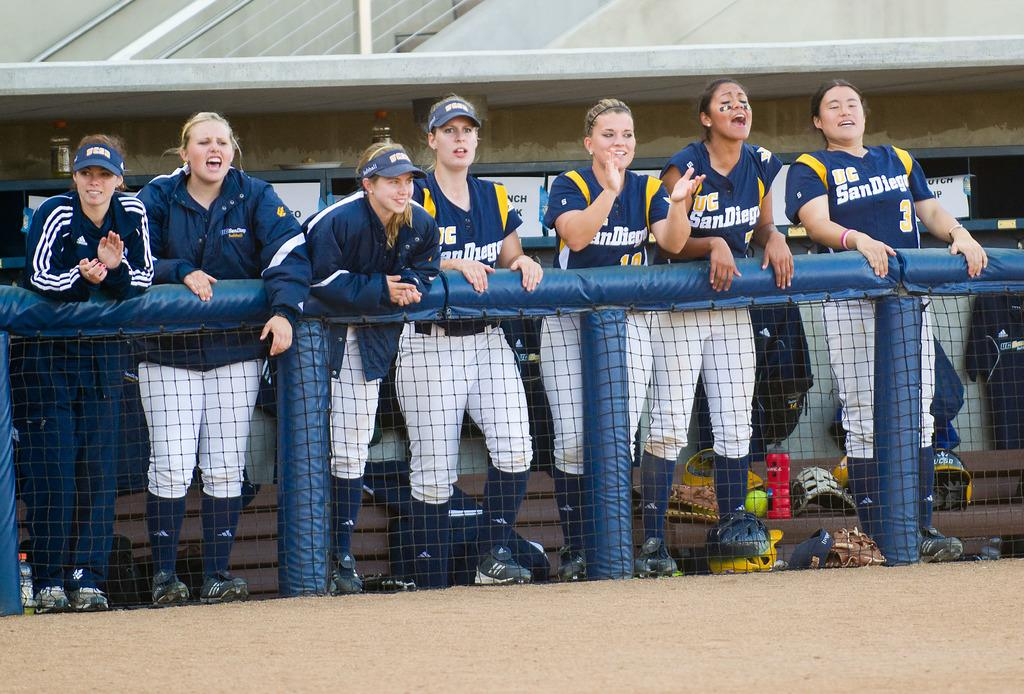<image>
Summarize the visual content of the image. the city of San Diego that is written on a jersey 